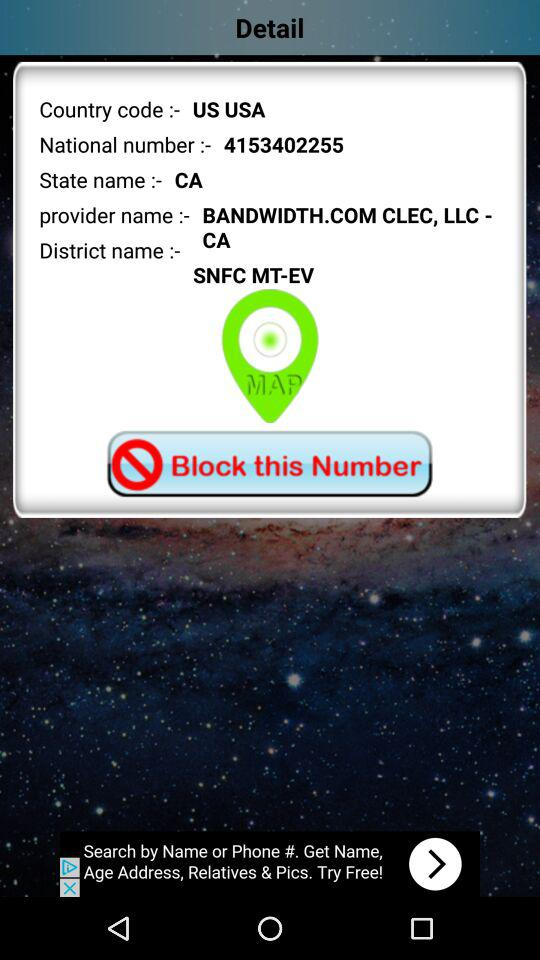What is the provider name? The provider name is Bandwidth.com Clec, LLC - CA. 